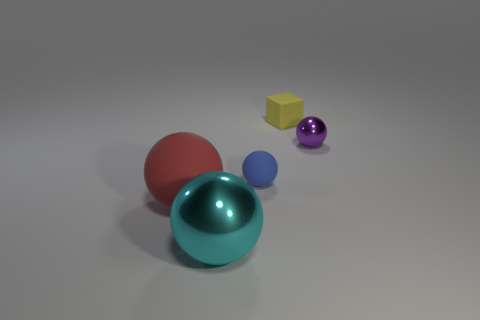The red rubber thing is what size?
Keep it short and to the point. Large. Is the number of large red rubber balls to the left of the red rubber sphere greater than the number of big green rubber cubes?
Offer a very short reply. No. How many small spheres are behind the small blue rubber ball?
Your answer should be compact. 1. Is there a brown shiny cylinder that has the same size as the purple metallic thing?
Provide a short and direct response. No. There is another big object that is the same shape as the red thing; what is its color?
Offer a very short reply. Cyan. Are there an equal number of purple metallic objects and large rubber cylinders?
Make the answer very short. No. Does the shiny thing that is to the left of the blue matte sphere have the same size as the shiny sphere behind the large matte sphere?
Make the answer very short. No. Are there any big rubber objects of the same shape as the purple metal object?
Offer a terse response. Yes. Are there the same number of cyan metallic things that are right of the large cyan sphere and matte cubes?
Make the answer very short. No. Is the size of the purple metal thing the same as the matte thing that is to the right of the small rubber sphere?
Provide a short and direct response. Yes. 